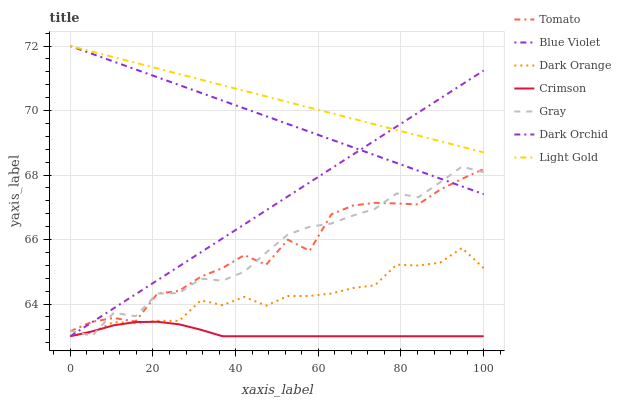Does Crimson have the minimum area under the curve?
Answer yes or no. Yes. Does Light Gold have the maximum area under the curve?
Answer yes or no. Yes. Does Dark Orange have the minimum area under the curve?
Answer yes or no. No. Does Dark Orange have the maximum area under the curve?
Answer yes or no. No. Is Dark Orchid the smoothest?
Answer yes or no. Yes. Is Tomato the roughest?
Answer yes or no. Yes. Is Dark Orange the smoothest?
Answer yes or no. No. Is Dark Orange the roughest?
Answer yes or no. No. Does Gray have the lowest value?
Answer yes or no. No. Does Blue Violet have the highest value?
Answer yes or no. Yes. Does Dark Orange have the highest value?
Answer yes or no. No. Is Tomato less than Light Gold?
Answer yes or no. Yes. Is Light Gold greater than Dark Orange?
Answer yes or no. Yes. Does Crimson intersect Gray?
Answer yes or no. Yes. Is Crimson less than Gray?
Answer yes or no. No. Is Crimson greater than Gray?
Answer yes or no. No. Does Tomato intersect Light Gold?
Answer yes or no. No. 